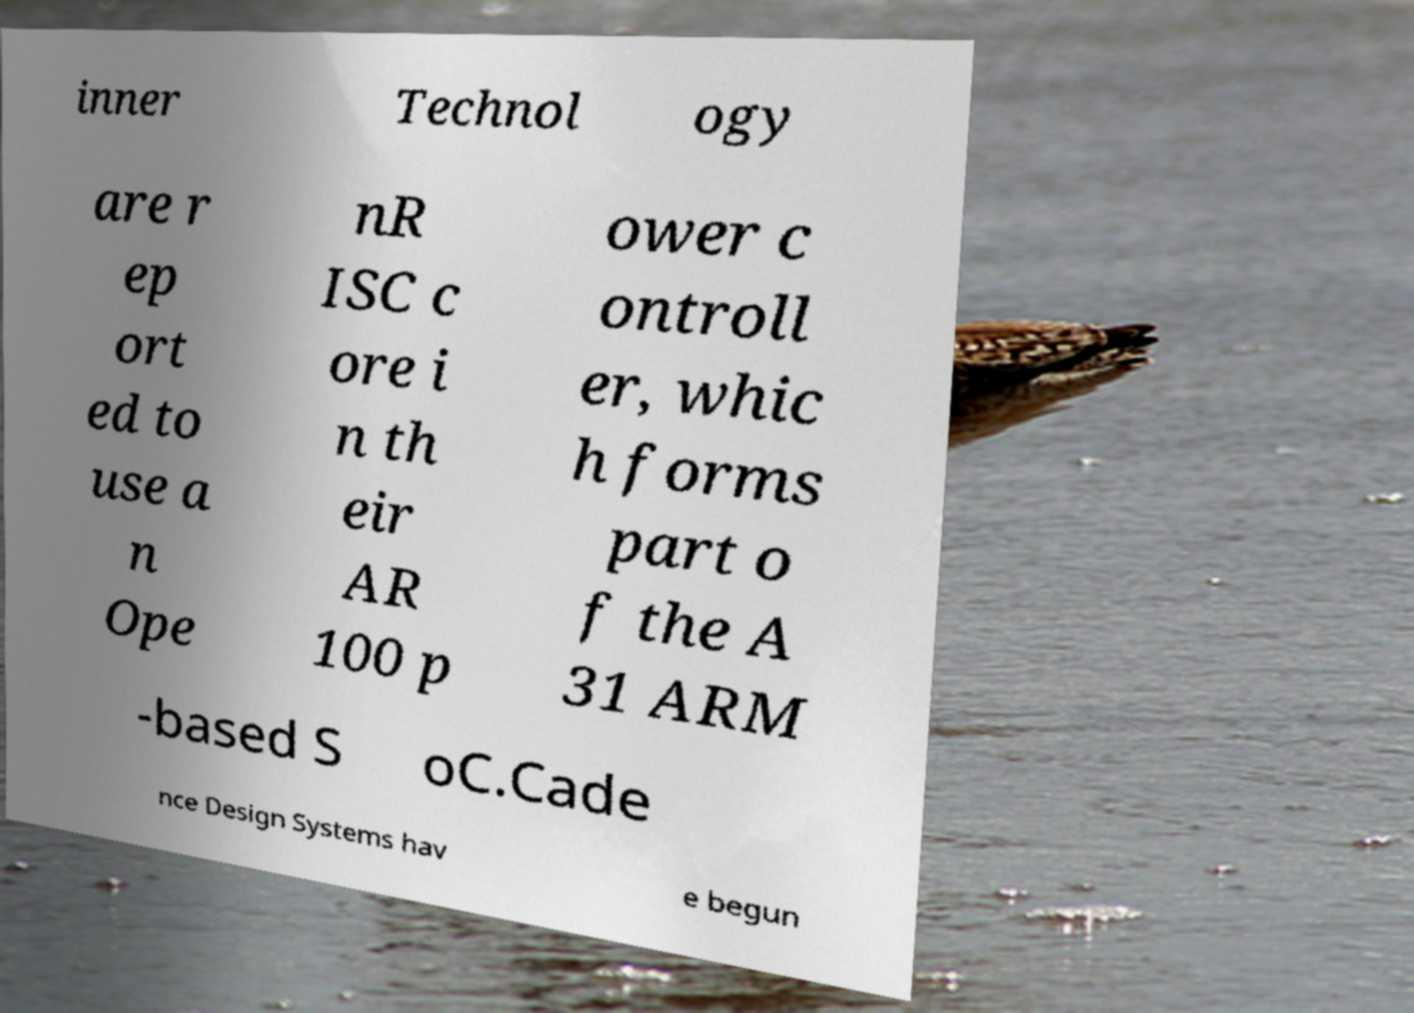There's text embedded in this image that I need extracted. Can you transcribe it verbatim? inner Technol ogy are r ep ort ed to use a n Ope nR ISC c ore i n th eir AR 100 p ower c ontroll er, whic h forms part o f the A 31 ARM -based S oC.Cade nce Design Systems hav e begun 